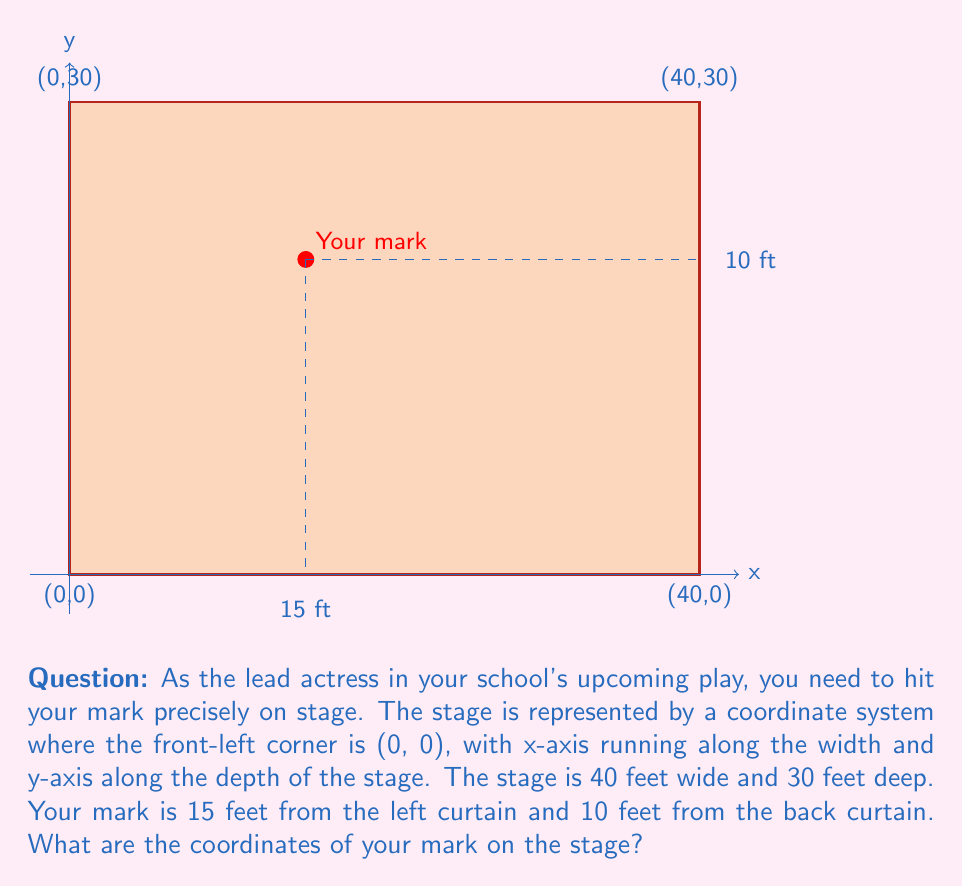Teach me how to tackle this problem. Let's approach this step-by-step:

1) In this coordinate system:
   - The x-coordinate represents the distance from the left curtain
   - The y-coordinate represents the distance from the front of the stage

2) We're given that the mark is 15 feet from the left curtain. This directly gives us the x-coordinate:

   $x = 15$

3) For the y-coordinate, we need to calculate the distance from the front of the stage. We know:
   - The stage is 30 feet deep
   - The mark is 10 feet from the back curtain

4) To find the distance from the front, we subtract the distance from the back from the total depth:

   $y = 30 - 10 = 20$

5) Therefore, the coordinates of the mark are $(15, 20)$.

We can verify this:
- The x-coordinate (15) is indeed 15 feet from the left curtain
- The y-coordinate (20) is 20 feet from the front, which means it's 10 feet from the back (30 - 20 = 10)
Answer: $(15, 20)$ 